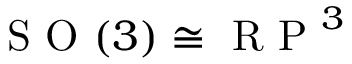Convert formula to latex. <formula><loc_0><loc_0><loc_500><loc_500>S O ( 3 ) \cong R P ^ { 3 }</formula> 